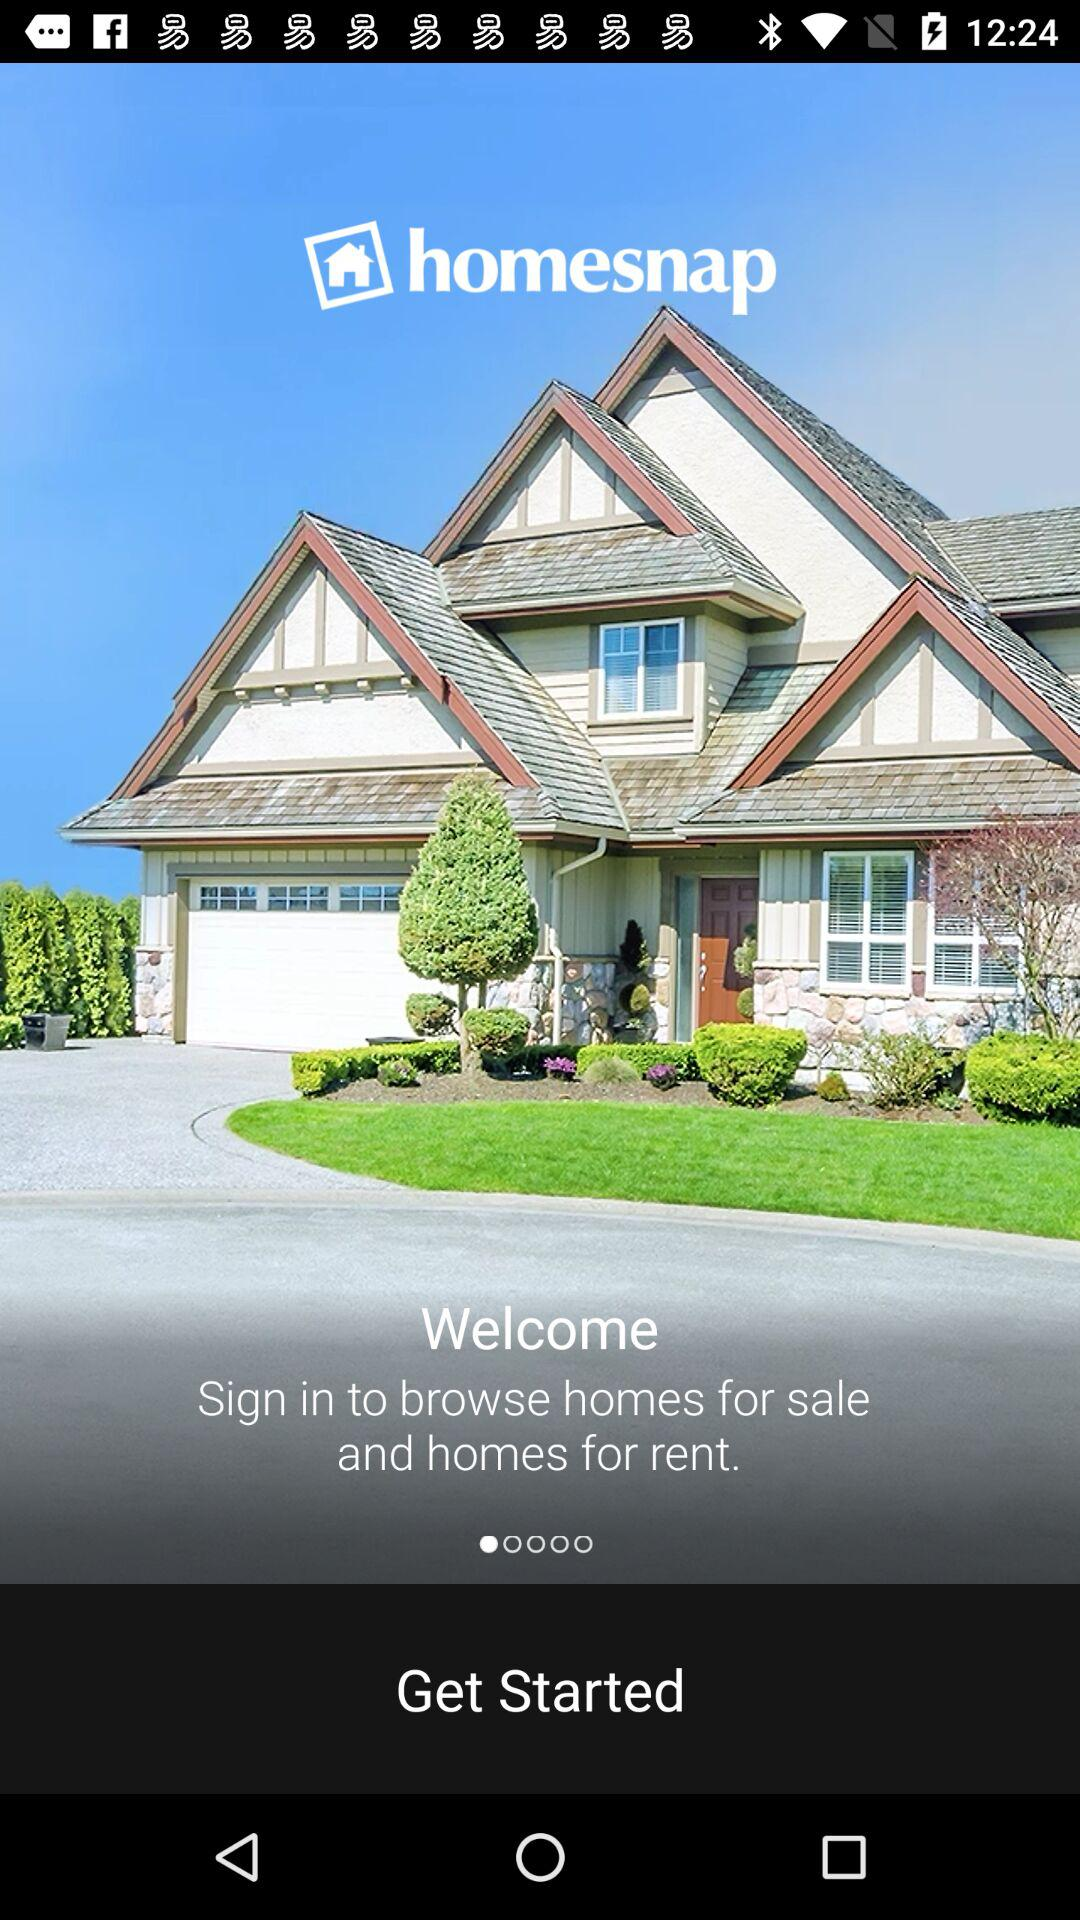What is the application name? The application name is "homesnap". 